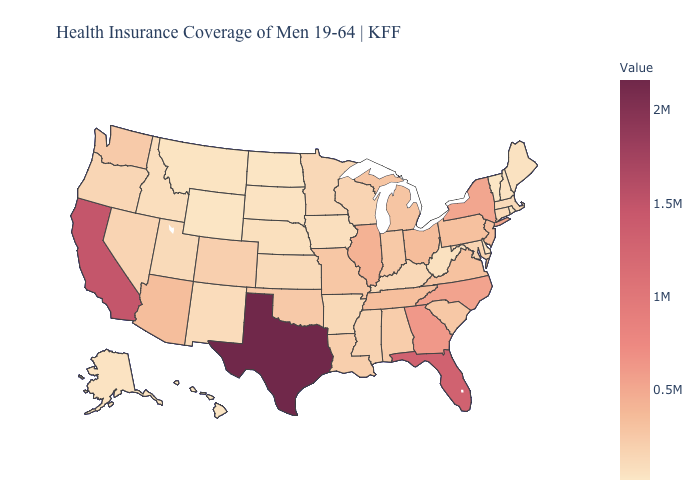Among the states that border Kansas , does Oklahoma have the highest value?
Be succinct. No. Among the states that border Kansas , does Nebraska have the lowest value?
Short answer required. Yes. Does West Virginia have a lower value than Georgia?
Give a very brief answer. Yes. Does California have the highest value in the West?
Write a very short answer. Yes. 